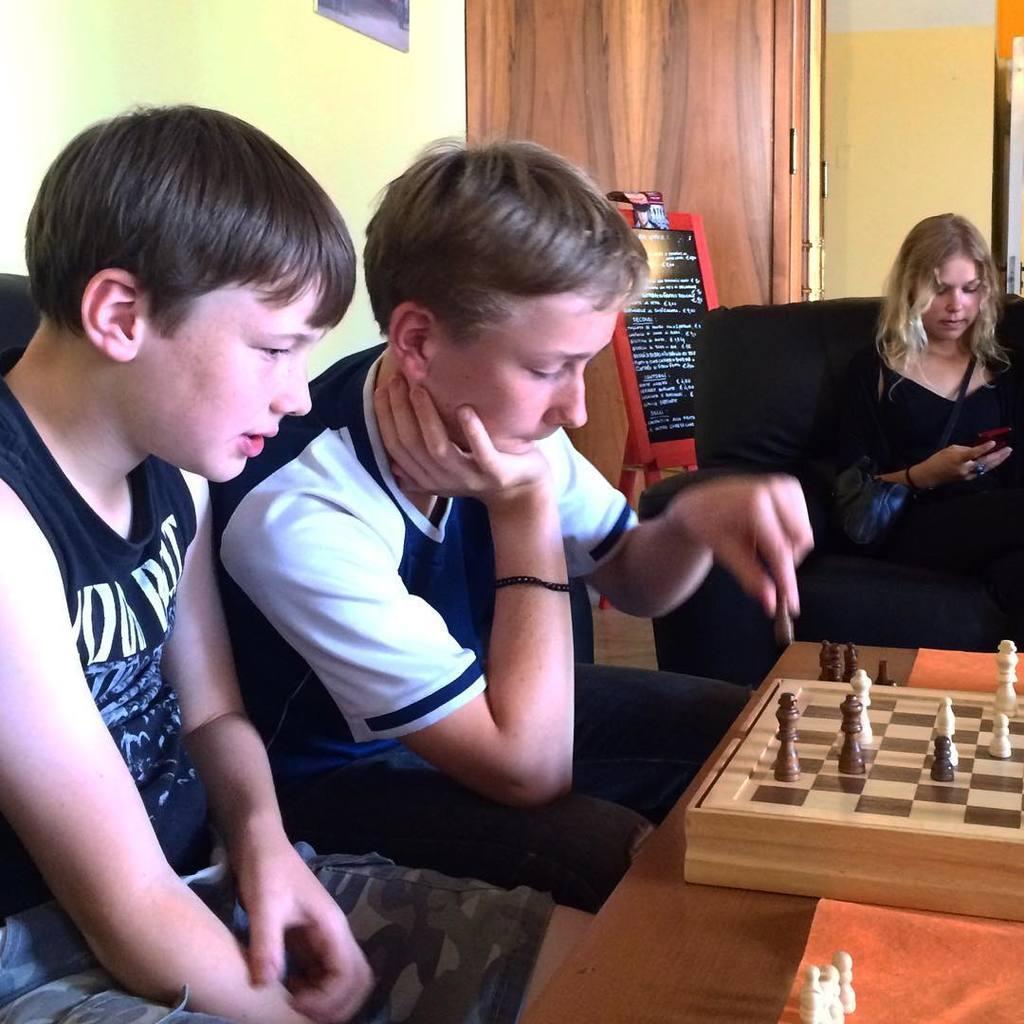How many people are in the picture? There are three people in the picture. What are two of the people doing in the picture? Two of the people are playing chess. What is the third person holding in the picture? One of the people is holding a phone. What type of circle is visible on the chessboard in the image? There is no circle visible on the chessboard in the image; it is a square board with alternating black and white squares. 